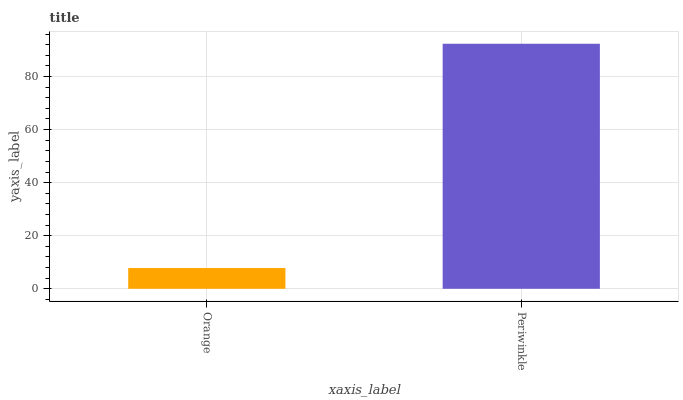Is Orange the minimum?
Answer yes or no. Yes. Is Periwinkle the maximum?
Answer yes or no. Yes. Is Periwinkle the minimum?
Answer yes or no. No. Is Periwinkle greater than Orange?
Answer yes or no. Yes. Is Orange less than Periwinkle?
Answer yes or no. Yes. Is Orange greater than Periwinkle?
Answer yes or no. No. Is Periwinkle less than Orange?
Answer yes or no. No. Is Periwinkle the high median?
Answer yes or no. Yes. Is Orange the low median?
Answer yes or no. Yes. Is Orange the high median?
Answer yes or no. No. Is Periwinkle the low median?
Answer yes or no. No. 